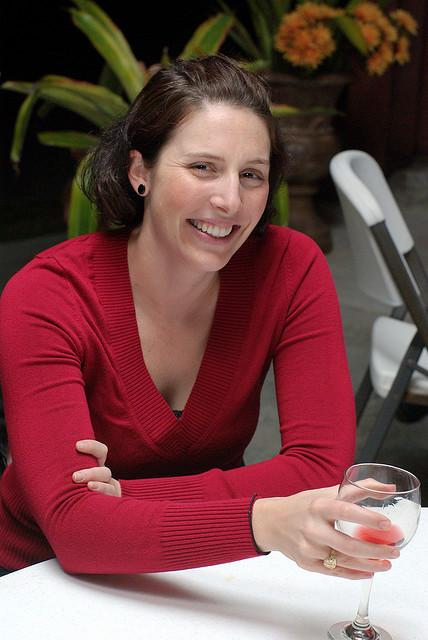What drink goes in this type of glass? wine 